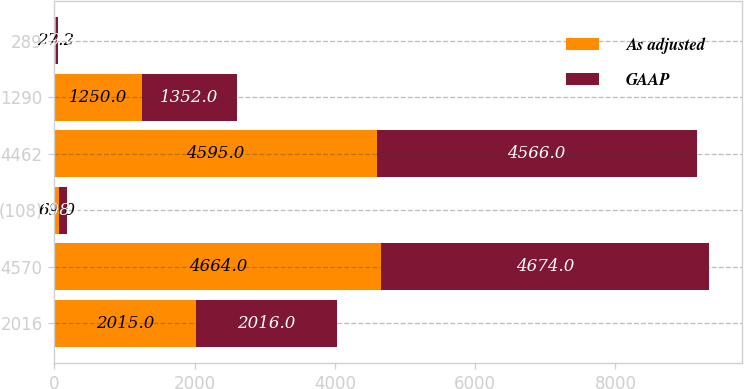<chart> <loc_0><loc_0><loc_500><loc_500><stacked_bar_chart><ecel><fcel>2016<fcel>4570<fcel>(108)<fcel>4462<fcel>1290<fcel>289<nl><fcel>As adjusted<fcel>2015<fcel>4664<fcel>69<fcel>4595<fcel>1250<fcel>27.2<nl><fcel>GAAP<fcel>2016<fcel>4674<fcel>108<fcel>4566<fcel>1352<fcel>29.6<nl></chart> 